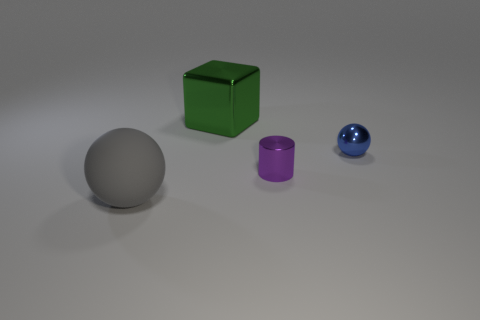Subtract all blue balls. How many balls are left? 1 Subtract 1 balls. How many balls are left? 1 Subtract all blocks. How many objects are left? 3 Add 4 big gray matte balls. How many objects exist? 8 Subtract all large purple shiny spheres. Subtract all tiny blue objects. How many objects are left? 3 Add 4 tiny blue balls. How many tiny blue balls are left? 5 Add 1 gray shiny balls. How many gray shiny balls exist? 1 Subtract 0 gray cylinders. How many objects are left? 4 